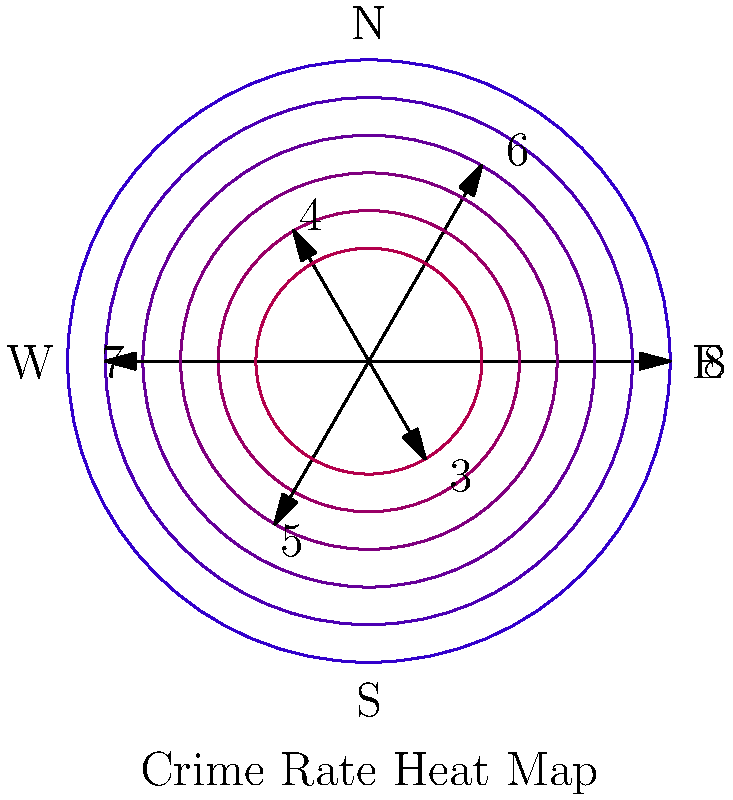Based on the polar heat map of crime rates in different neighborhoods, which direction shows the highest crime rate, and how might this information influence evidence-based policy decisions for urban planning and law enforcement resource allocation? To answer this question, we need to analyze the polar heat map and understand its implications for policy-making:

1. Interpret the map:
   - The map shows crime rates in different directions (neighborhoods) using a color-coded heat map and numerical values.
   - Each direction is represented by an arrow, with the length and color intensity indicating the crime rate.
   - Higher values and redder colors represent higher crime rates.

2. Identify the highest crime rate:
   - North (top): 8
   - Northeast: 6
   - Southeast: 4
   - South: 7
   - Southwest: 5
   - Northwest: 3
   - The highest value is 8, corresponding to the North direction.

3. Evidence-based policy implications:
   a) Resource allocation:
      - Allocate more law enforcement resources to the northern neighborhood.
      - Implement targeted patrols and community policing initiatives in high-crime areas.

   b) Urban planning:
      - Analyze environmental factors contributing to higher crime rates in the north.
      - Implement crime prevention through environmental design (CPTED) principles.

   c) Social programs:
      - Invest in education, job training, and community development programs in high-crime areas.
      - Address root causes of crime through data-driven social interventions.

   d) Monitoring and evaluation:
      - Establish a data collection and analysis system to track the effectiveness of implemented policies.
      - Regularly update the crime rate map to assess the impact of interventions.

   e) Collaborative approach:
      - Foster partnerships between law enforcement, community organizations, and local businesses.
      - Encourage data sharing and collaborative problem-solving among stakeholders.

By using this data-driven approach, policymakers can make informed decisions to efficiently allocate resources and implement targeted strategies to reduce crime rates across all neighborhoods.
Answer: North; prioritize resources in northern neighborhood, implement targeted interventions, and continuously monitor data for policy effectiveness. 